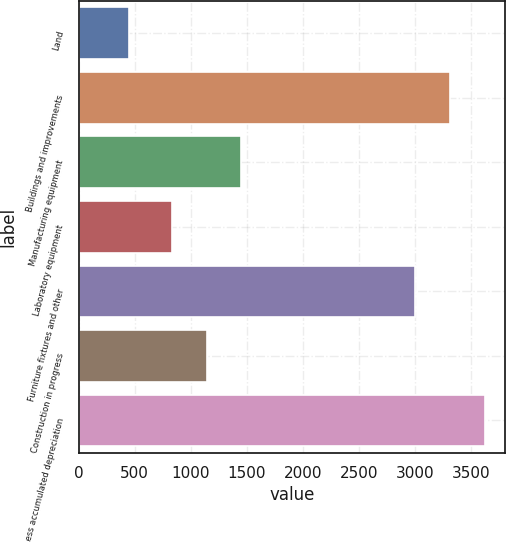Convert chart to OTSL. <chart><loc_0><loc_0><loc_500><loc_500><bar_chart><fcel>Land<fcel>Buildings and improvements<fcel>Manufacturing equipment<fcel>Laboratory equipment<fcel>Furniture fixtures and other<fcel>Construction in progress<fcel>Less accumulated depreciation<nl><fcel>451<fcel>3313.9<fcel>1452.8<fcel>831<fcel>3003<fcel>1141.9<fcel>3624.8<nl></chart> 